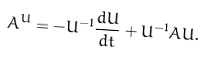Convert formula to latex. <formula><loc_0><loc_0><loc_500><loc_500>A ^ { U } = - U ^ { - 1 } \frac { d U } { d t } + U ^ { - 1 } A U .</formula> 